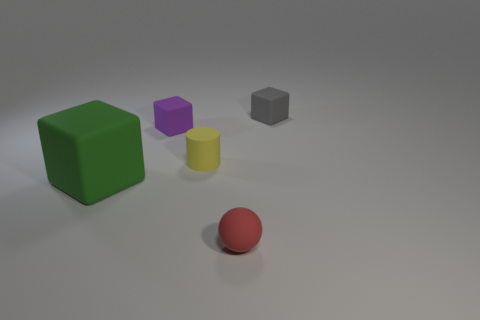Does the small cube to the left of the red sphere have the same material as the small red object?
Provide a succinct answer. Yes. Are there an equal number of red balls behind the small red sphere and matte blocks that are in front of the gray rubber object?
Keep it short and to the point. No. Is there any other thing that has the same size as the green matte object?
Your response must be concise. No. There is a small cube that is on the left side of the tiny thing that is in front of the large green cube; are there any small rubber objects behind it?
Your response must be concise. Yes. There is a small thing in front of the big green thing; does it have the same shape as the tiny matte object to the right of the tiny red sphere?
Your answer should be compact. No. Are there more tiny rubber cubes that are to the left of the yellow cylinder than red blocks?
Make the answer very short. Yes. What number of objects are big blue metallic cylinders or matte blocks?
Offer a very short reply. 3. What color is the tiny rubber cylinder?
Provide a succinct answer. Yellow. There is a tiny gray cube; are there any blocks to the left of it?
Make the answer very short. Yes. There is a tiny rubber cube that is to the left of the small matte block that is right of the tiny cube on the left side of the gray thing; what color is it?
Your answer should be very brief. Purple. 